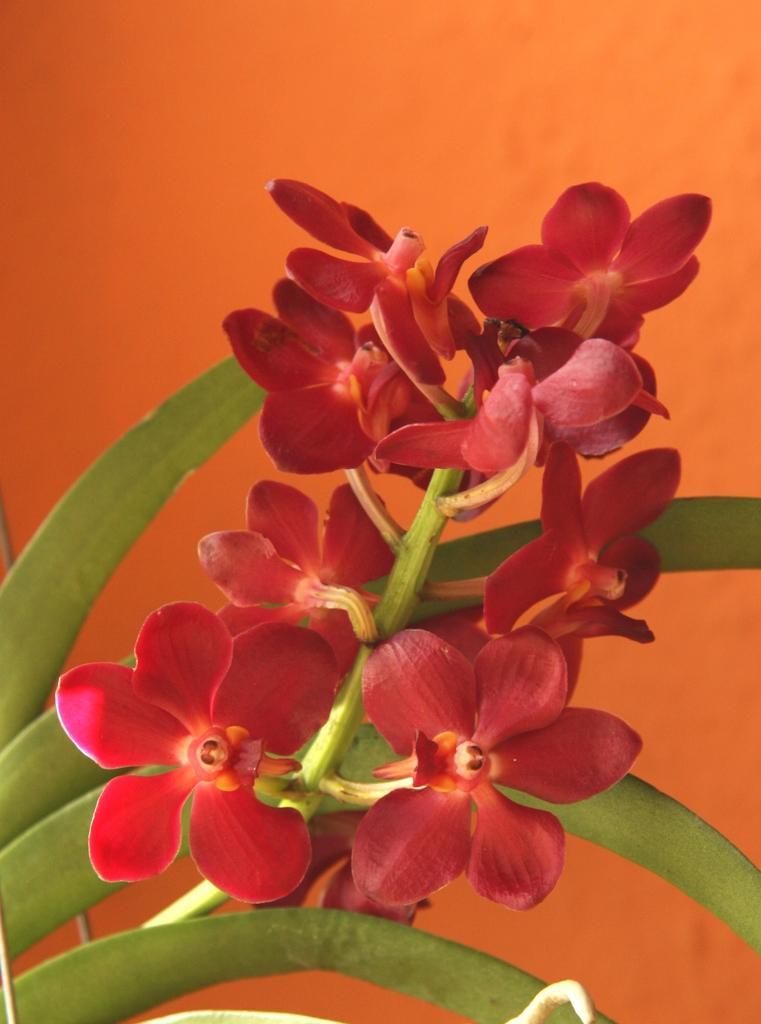Please provide a concise description of this image. In this picture we can see some red flowers on a plant. Background is orange in color. 